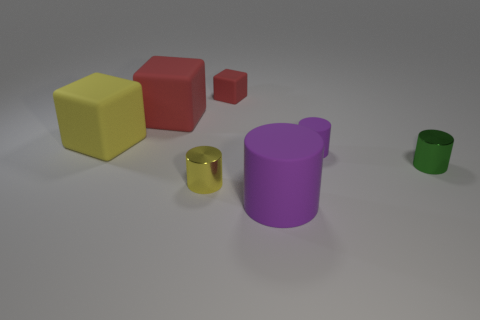Are the small green thing and the tiny cube made of the same material?
Your answer should be compact. No. What number of other objects are there of the same size as the green cylinder?
Offer a terse response. 3. What color is the cylinder that is on the right side of the purple thing behind the large purple matte cylinder?
Keep it short and to the point. Green. What number of other things are there of the same shape as the large yellow rubber object?
Keep it short and to the point. 2. Are there any things that have the same material as the small red cube?
Provide a short and direct response. Yes. There is a yellow cylinder that is the same size as the green metallic cylinder; what is it made of?
Ensure brevity in your answer.  Metal. What is the color of the large thing right of the small cylinder in front of the object that is to the right of the tiny purple cylinder?
Provide a succinct answer. Purple. There is a red thing that is on the right side of the small yellow cylinder; does it have the same shape as the yellow object that is behind the small green metallic cylinder?
Your response must be concise. Yes. What number of small green rubber things are there?
Offer a terse response. 0. There is a shiny object that is the same size as the yellow metallic cylinder; what color is it?
Offer a very short reply. Green. 